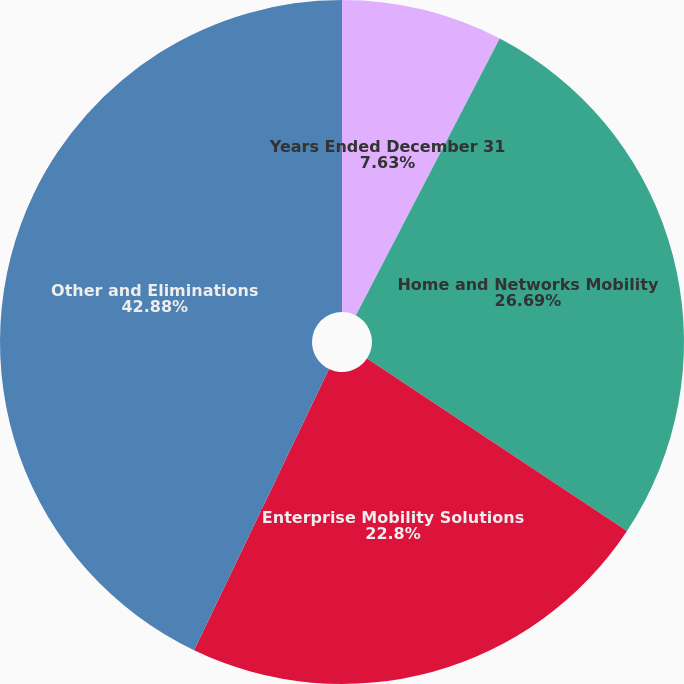Convert chart. <chart><loc_0><loc_0><loc_500><loc_500><pie_chart><fcel>Years Ended December 31<fcel>Home and Networks Mobility<fcel>Enterprise Mobility Solutions<fcel>Other and Eliminations<nl><fcel>7.63%<fcel>26.69%<fcel>22.8%<fcel>42.88%<nl></chart> 